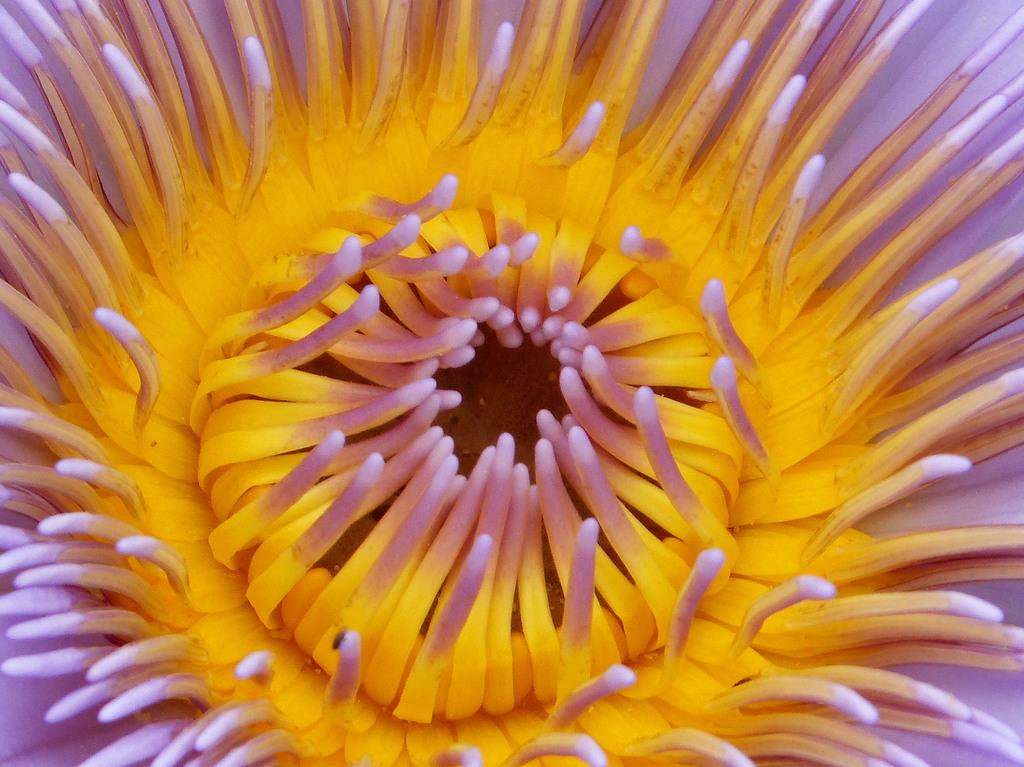What is the main subject of the image? There is a flower in the image. What is the weather like in the image? The fact provided does not mention the weather, so it cannot be determined from the image. 